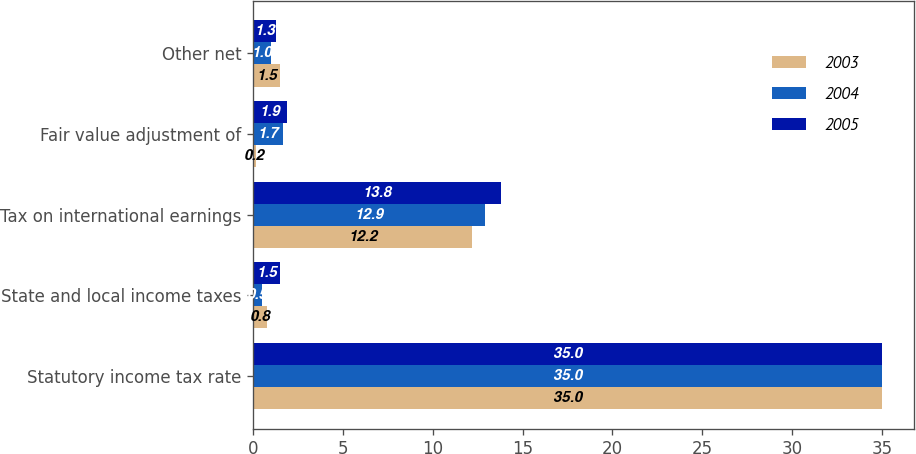Convert chart. <chart><loc_0><loc_0><loc_500><loc_500><stacked_bar_chart><ecel><fcel>Statutory income tax rate<fcel>State and local income taxes<fcel>Tax on international earnings<fcel>Fair value adjustment of<fcel>Other net<nl><fcel>2003<fcel>35<fcel>0.8<fcel>12.2<fcel>0.2<fcel>1.5<nl><fcel>2004<fcel>35<fcel>0.5<fcel>12.9<fcel>1.7<fcel>1<nl><fcel>2005<fcel>35<fcel>1.5<fcel>13.8<fcel>1.9<fcel>1.3<nl></chart> 